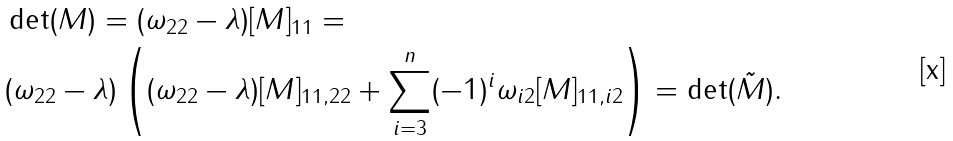Convert formula to latex. <formula><loc_0><loc_0><loc_500><loc_500>& \det ( M ) = ( \omega _ { 2 2 } - \lambda ) [ M ] _ { 1 1 } = \\ & ( \omega _ { 2 2 } - \lambda ) \left ( ( \omega _ { 2 2 } - \lambda ) [ M ] _ { 1 1 , 2 2 } + \sum _ { i = 3 } ^ { n } ( - 1 ) ^ { i } \omega _ { i 2 } [ M ] _ { 1 1 , i 2 } \right ) = \det ( \tilde { M } ) .</formula> 